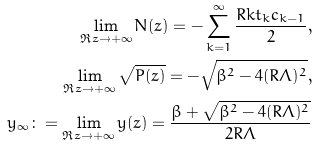<formula> <loc_0><loc_0><loc_500><loc_500>\lim _ { \Re z \to + \infty } N ( z ) = - \sum _ { k = 1 } ^ { \infty } \frac { R k t _ { k } c _ { k - 1 } } { 2 } , \\ \lim _ { \Re z \to + \infty } \sqrt { P ( z ) } = - \sqrt { \beta ^ { 2 } - 4 ( R \Lambda ) ^ { 2 } } , \\ y _ { \infty } \colon = \lim _ { \Re z \to + \infty } y ( z ) = \frac { \beta + \sqrt { \beta ^ { 2 } - 4 ( R \Lambda ) ^ { 2 } } } { 2 R \Lambda }</formula> 